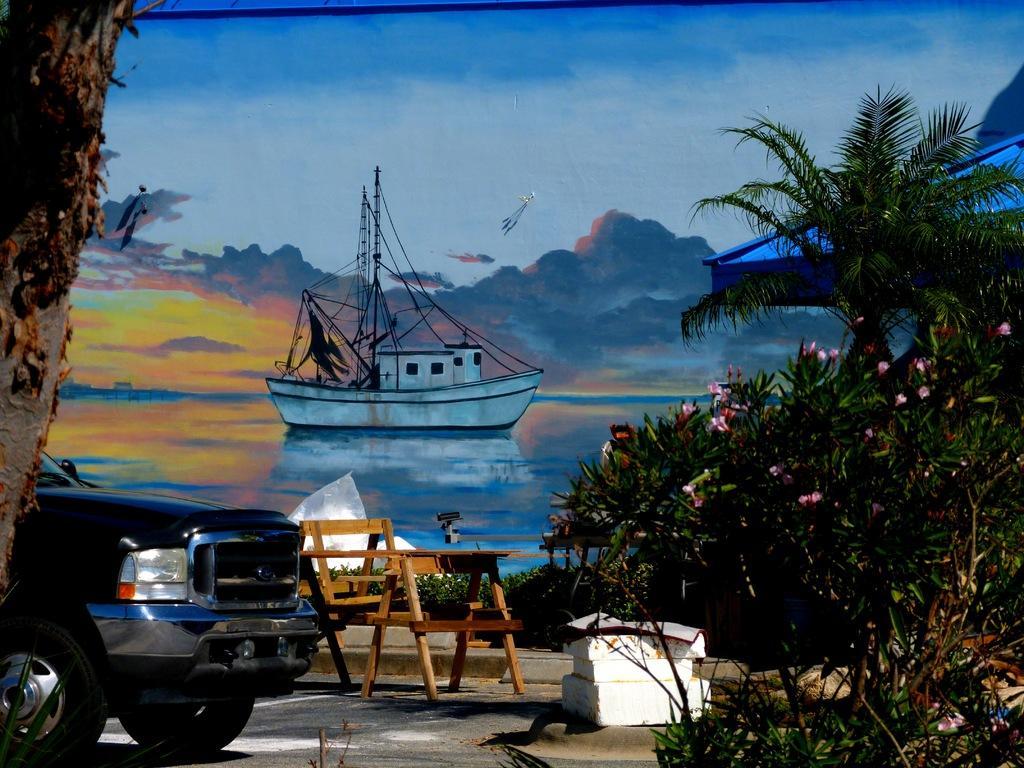How would you summarize this image in a sentence or two? As we can see in the image, there is a painting. In painting there is water. On water there is a boat. On the top there is sky and clouds. In the front there is a tree stem, a car, bench and some trees. 